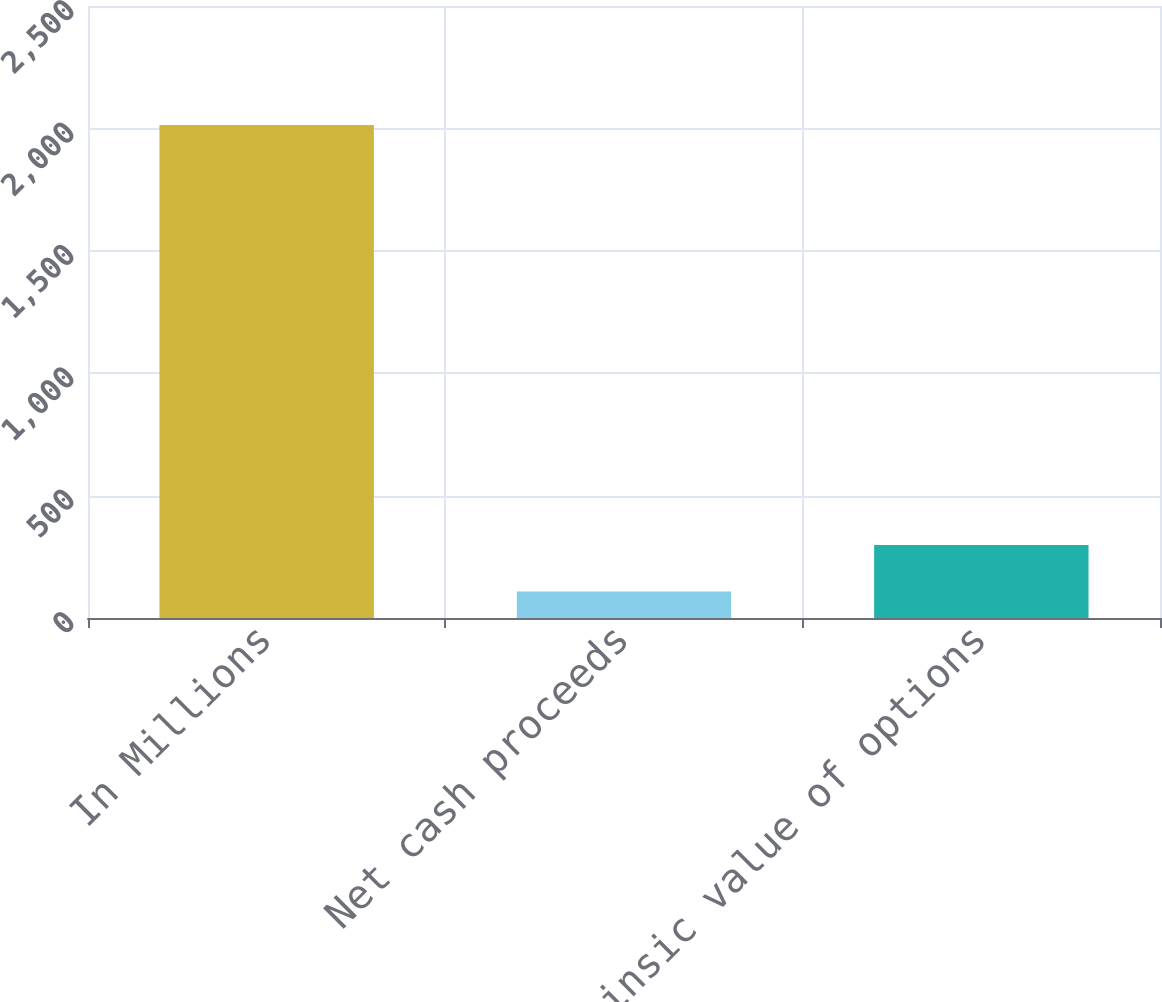Convert chart. <chart><loc_0><loc_0><loc_500><loc_500><bar_chart><fcel>In Millions<fcel>Net cash proceeds<fcel>Intrinsic value of options<nl><fcel>2014<fcel>108.1<fcel>298.69<nl></chart> 